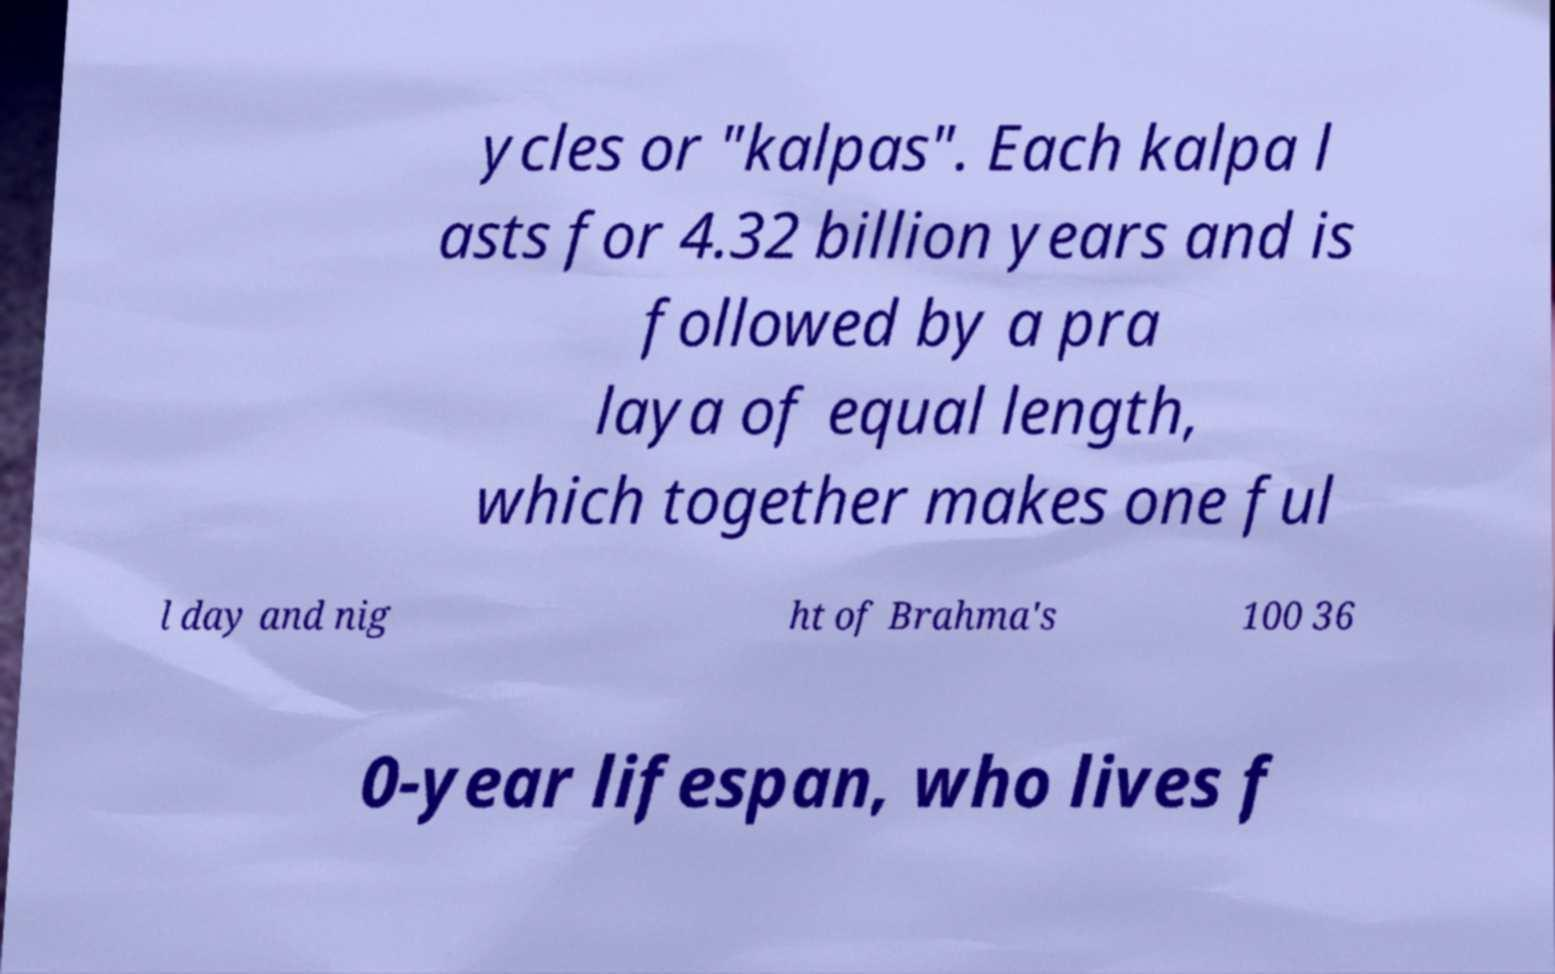I need the written content from this picture converted into text. Can you do that? ycles or "kalpas". Each kalpa l asts for 4.32 billion years and is followed by a pra laya of equal length, which together makes one ful l day and nig ht of Brahma's 100 36 0-year lifespan, who lives f 